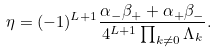<formula> <loc_0><loc_0><loc_500><loc_500>\eta = ( - 1 ) ^ { L + 1 } \frac { \alpha _ { - } \beta _ { + } + \alpha _ { + } \beta _ { - } } { 4 ^ { L + 1 } \prod _ { k \neq 0 } \Lambda _ { k } } .</formula> 